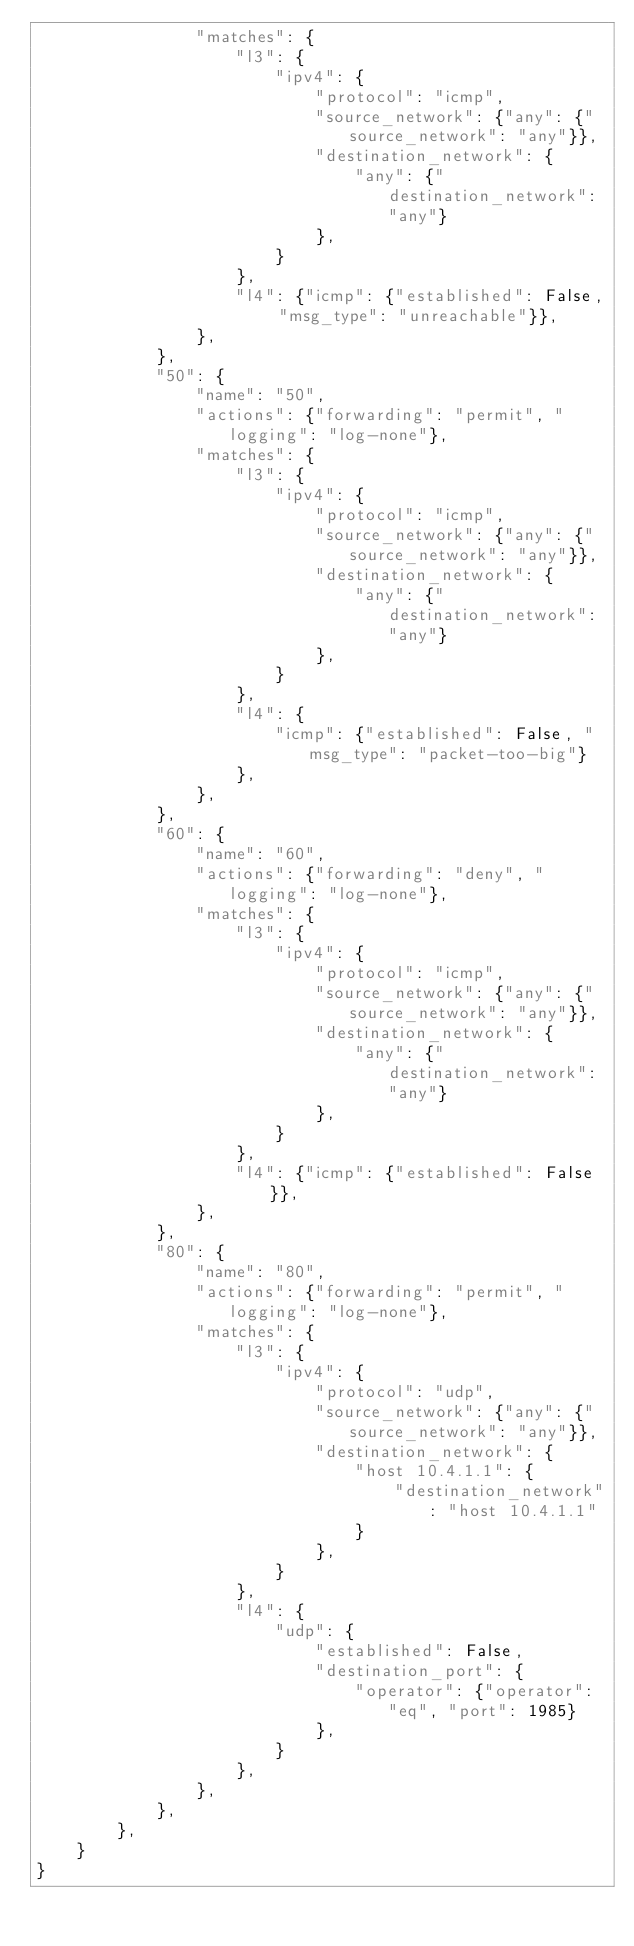Convert code to text. <code><loc_0><loc_0><loc_500><loc_500><_Python_>                "matches": {
                    "l3": {
                        "ipv4": {
                            "protocol": "icmp",
                            "source_network": {"any": {"source_network": "any"}},
                            "destination_network": {
                                "any": {"destination_network": "any"}
                            },
                        }
                    },
                    "l4": {"icmp": {"established": False, "msg_type": "unreachable"}},
                },
            },
            "50": {
                "name": "50",
                "actions": {"forwarding": "permit", "logging": "log-none"},
                "matches": {
                    "l3": {
                        "ipv4": {
                            "protocol": "icmp",
                            "source_network": {"any": {"source_network": "any"}},
                            "destination_network": {
                                "any": {"destination_network": "any"}
                            },
                        }
                    },
                    "l4": {
                        "icmp": {"established": False, "msg_type": "packet-too-big"}
                    },
                },
            },
            "60": {
                "name": "60",
                "actions": {"forwarding": "deny", "logging": "log-none"},
                "matches": {
                    "l3": {
                        "ipv4": {
                            "protocol": "icmp",
                            "source_network": {"any": {"source_network": "any"}},
                            "destination_network": {
                                "any": {"destination_network": "any"}
                            },
                        }
                    },
                    "l4": {"icmp": {"established": False}},
                },
            },
            "80": {
                "name": "80",
                "actions": {"forwarding": "permit", "logging": "log-none"},
                "matches": {
                    "l3": {
                        "ipv4": {
                            "protocol": "udp",
                            "source_network": {"any": {"source_network": "any"}},
                            "destination_network": {
                                "host 10.4.1.1": {
                                    "destination_network": "host 10.4.1.1"
                                }
                            },
                        }
                    },
                    "l4": {
                        "udp": {
                            "established": False,
                            "destination_port": {
                                "operator": {"operator": "eq", "port": 1985}
                            },
                        }
                    },
                },
            },
        },
    }
}
</code> 